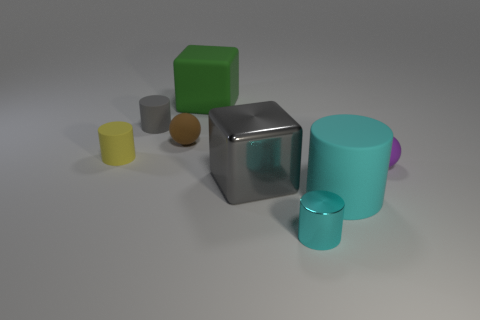Subtract all large cylinders. How many cylinders are left? 3 Subtract all cyan cylinders. How many cylinders are left? 2 Add 1 big green blocks. How many objects exist? 9 Subtract all spheres. How many objects are left? 6 Subtract 2 cylinders. How many cylinders are left? 2 Add 6 large rubber cylinders. How many large rubber cylinders are left? 7 Add 2 balls. How many balls exist? 4 Subtract 0 blue cylinders. How many objects are left? 8 Subtract all gray spheres. Subtract all brown cylinders. How many spheres are left? 2 Subtract all brown blocks. How many blue balls are left? 0 